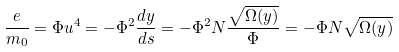<formula> <loc_0><loc_0><loc_500><loc_500>\frac { e } { m _ { 0 } } = \Phi u ^ { 4 } = - \Phi ^ { 2 } \frac { d y } { d s } = - \Phi ^ { 2 } N \frac { \sqrt { \Omega ( y ) } } { \Phi } = - \Phi N \sqrt { \Omega ( y ) }</formula> 